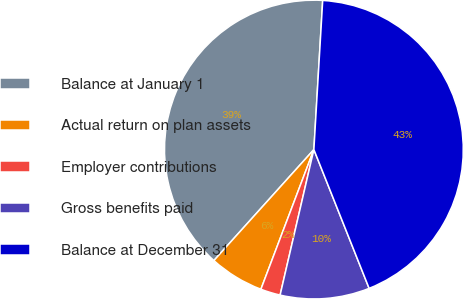<chart> <loc_0><loc_0><loc_500><loc_500><pie_chart><fcel>Balance at January 1<fcel>Actual return on plan assets<fcel>Employer contributions<fcel>Gross benefits paid<fcel>Balance at December 31<nl><fcel>39.27%<fcel>5.9%<fcel>2.14%<fcel>9.66%<fcel>43.03%<nl></chart> 